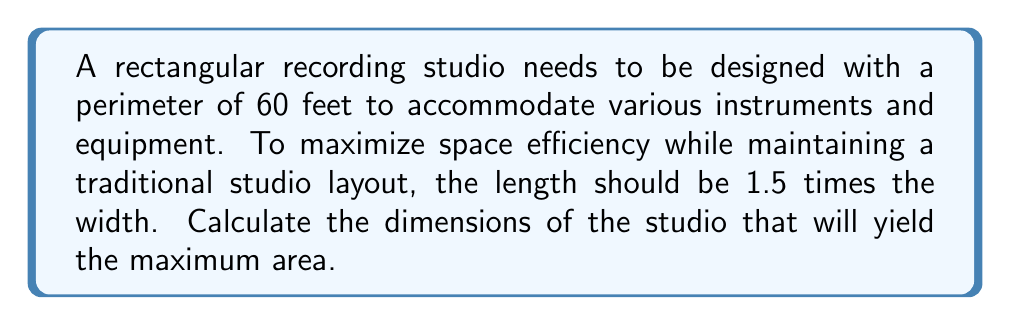Can you solve this math problem? Let's approach this step-by-step:

1) Let $w$ be the width of the studio and $l$ be the length.

2) Given that the length should be 1.5 times the width:
   $l = 1.5w$

3) The perimeter of a rectangle is given by $2l + 2w = 60$
   Substituting $l$ with $1.5w$:
   $2(1.5w) + 2w = 60$
   $3w + 2w = 60$
   $5w = 60$

4) Solving for $w$:
   $w = 60 / 5 = 12$ feet

5) Now we can calculate the length:
   $l = 1.5w = 1.5 * 12 = 18$ feet

6) To verify, let's check the perimeter:
   $2l + 2w = 2(18) + 2(12) = 36 + 24 = 60$ feet (which matches our given perimeter)

7) The area of the studio would be:
   $A = l * w = 18 * 12 = 216$ square feet

[asy]
unitsize(4mm);
draw((0,0)--(18,0)--(18,12)--(0,12)--cycle);
label("18 ft", (9,0), S);
label("12 ft", (0,6), W);
label("Recording Studio", (9,6), N);
[/asy]

This configuration maximizes the area while maintaining the 1.5:1 ratio between length and width, which is often preferred in traditional studio layouts for acoustic reasons and equipment placement.
Answer: $18$ feet long, $12$ feet wide 